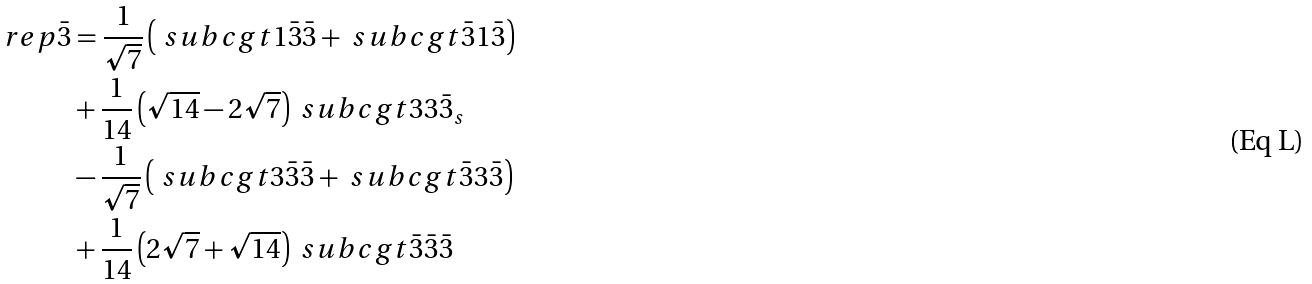<formula> <loc_0><loc_0><loc_500><loc_500>\ r e p { \bar { 3 } } & = \frac { 1 } { \sqrt { 7 } } \left ( \ s u b c g t { 1 } { \bar { 3 } } { \bar { 3 } } + \ s u b c g t { \bar { 3 } } { 1 } { \bar { 3 } } \right ) \\ & + \frac { 1 } { 1 4 } \left ( \sqrt { 1 4 } - 2 \sqrt { 7 } \right ) \ s u b c g t { 3 } { 3 } { \bar { 3 } _ { s } } \\ & - \frac { 1 } { \sqrt { 7 } } \left ( \ s u b c g t { 3 } { \bar { 3 } } { \bar { 3 } } + \ s u b c g t { \bar { 3 } } { 3 } { \bar { 3 } } \right ) \\ & + \frac { 1 } { 1 4 } \left ( 2 \sqrt { 7 } + \sqrt { 1 4 } \right ) \ s u b c g t { \bar { 3 } } { \bar { 3 } } { \bar { 3 } }</formula> 